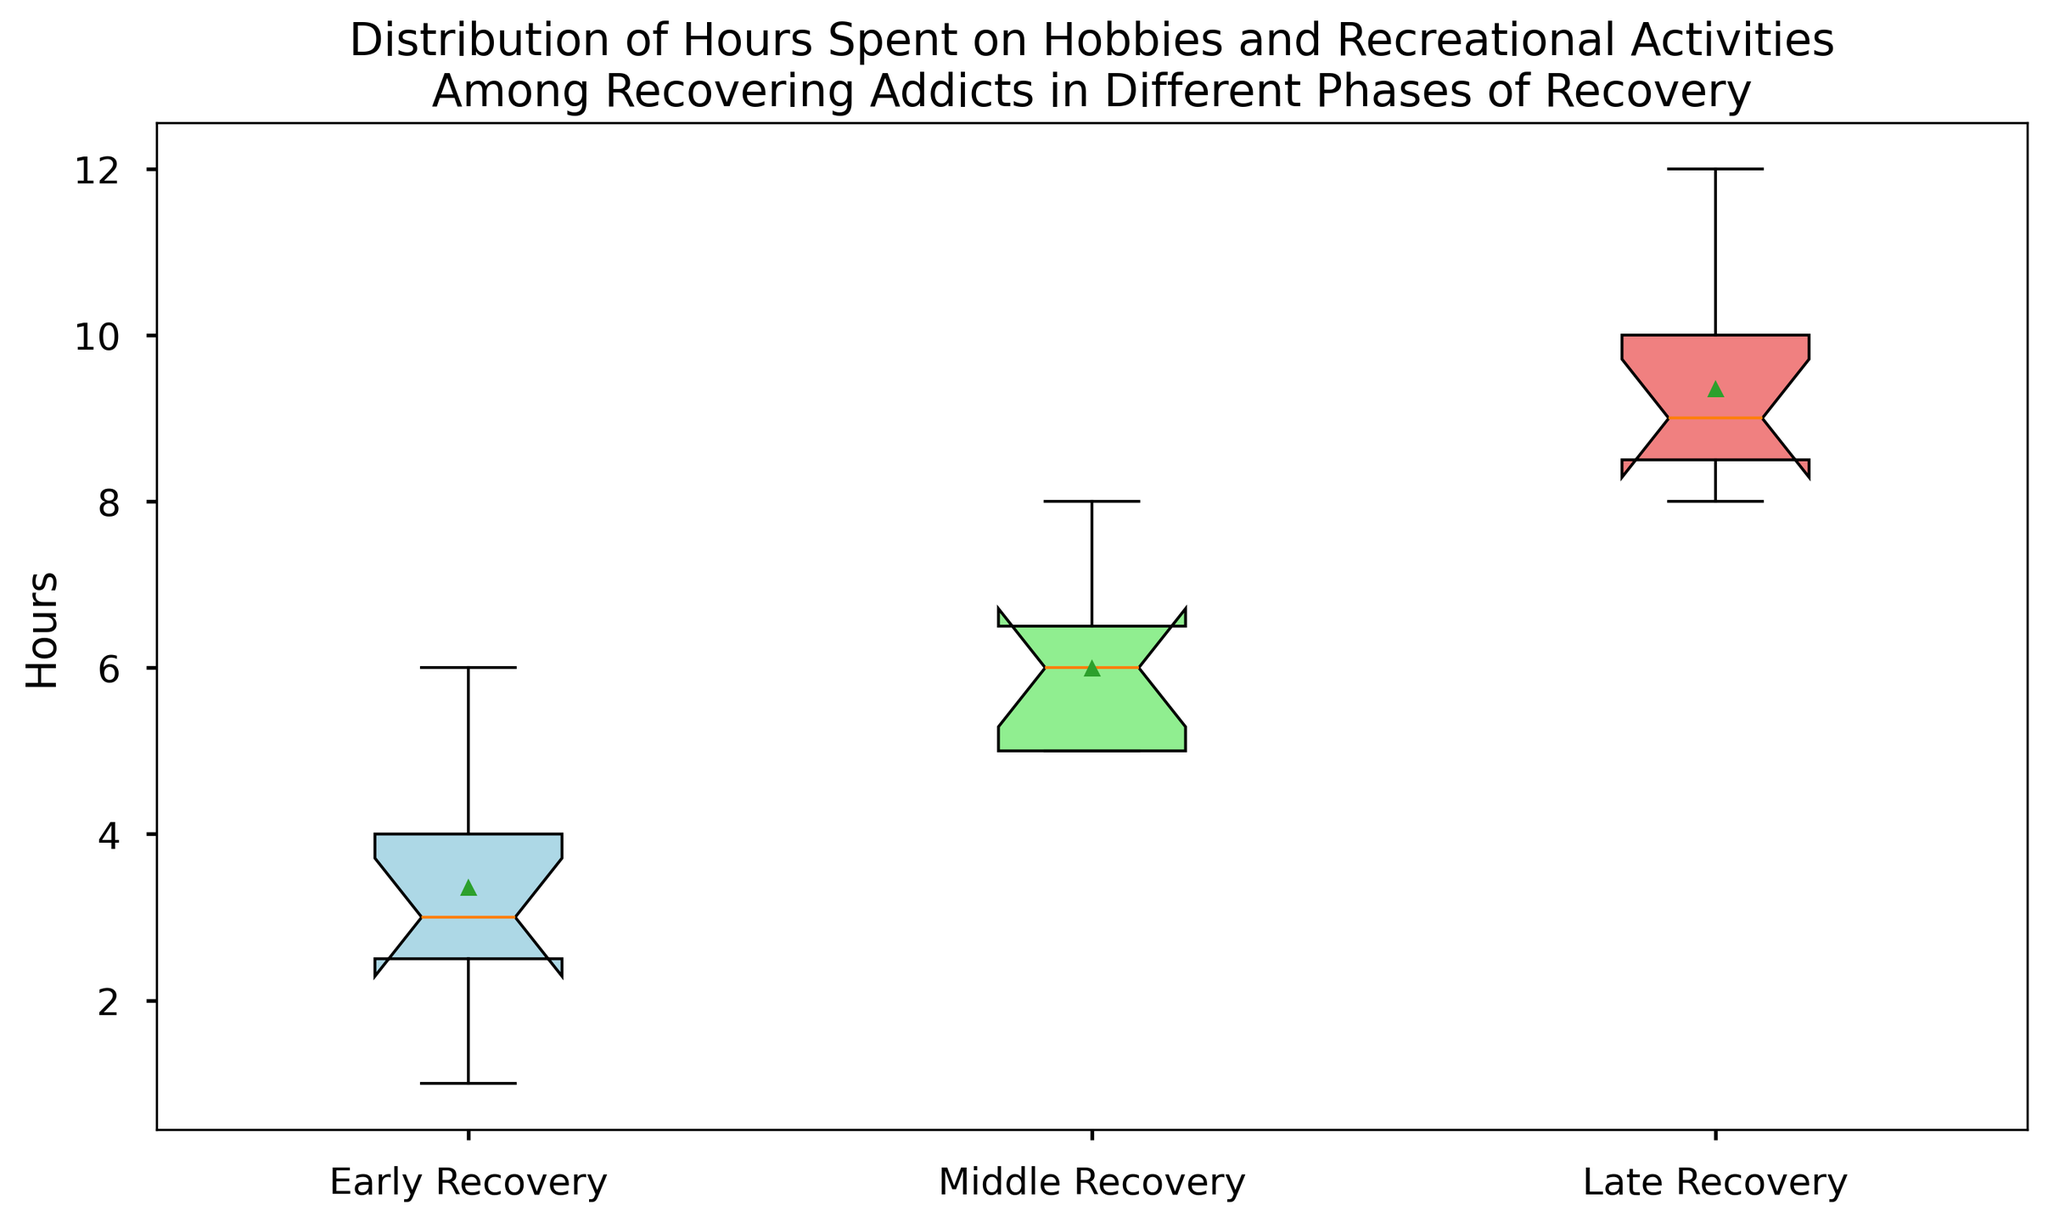What phase has the widest range of hours spent on hobbies and recreational activities? The range is calculated by subtracting the minimum value (lower whisker) from the maximum value (upper whisker) for each phase. In the figure, the Late Recovery phase shows the widest range between the minimum (8) and the maximum (12), which is 4 hours.
Answer: Late Recovery What is the median number of hours spent on hobbies and recreational activities during Early Recovery? The median is the middle value in the box plot where 50% of the values lie above and below. In the Early Recovery phase, the median is visibly at 3 hours.
Answer: 3 hours How do the mean hours in the Middle Recovery phase compare to those in the Early Recovery phase? The mean value is represented by the small dot within each box. In the Middle Recovery phase, the mean is around 6 hours, whereas in the Early Recovery phase, it is closer to 3.5 hours. The mean hours in Middle Recovery are higher than those in Early Recovery.
Answer: Middle Recovery has higher mean hours Which phase has the least variability in hours spent on hobbies and recreational activities? Variability can be observed by looking at the length of the box (interquartile range, IQR). The Early Recovery phase has the smallest box length, indicating less variability compared to Middle and Late Recovery phases.
Answer: Early Recovery Is the interquartile range (IQR) larger in Middle Recovery or Early Recovery? The IQR is the range between the first quartile (25th percentile, the bottom of the box) and the third quartile (75th percentile, the top of the box). In the Middle Recovery phase, the box is longer than that in the Early Recovery phase, indicating a larger IQR.
Answer: Middle Recovery What is the difference in the median hours between the Late Recovery and Early Recovery phases? The median values can be read at the line within the box for each phase. For Late Recovery, the median is 9 hours; for Early Recovery, it is 3 hours. The difference is 9 - 3 = 6 hours.
Answer: 6 hours Which phase has outliers, and what color are they marked with? Outliers are marked with small circles outside the whiskers of the box plot. The figure shows outliers in the Early Recovery phase, marked with red.
Answer: Early Recovery and red Does any phase in the figure show a mean value that is significantly higher or lower than the median? A significant difference between the mean (dot) and median (line within the box) could indicate skewness. The figure shows that, in all phases, the mean and median are close, with no significant differences.
Answer: No significant differences What visual difference is there between the mean and the median in the Middle Recovery phase? The mean is represented by a small dot, and the median by a line inside the box. In the Middle Recovery phase, both are visually close to each other at around 6 hours, indicating symmetry.
Answer: Both are around 6 hours and close in value How do the whiskers differ between the phases? Whiskers represent the range without outliers. In the Early Recovery phase, the whiskers extend from around 1 to 6 hours, in the Middle Recovery phase from 5 to 8 hours, and in the Late Recovery phase from 8 to 12 hours. These differences indicate the variability in the time spent.
Answer: They extend from 1-6, 5-8, and 8-12 hours respectively 